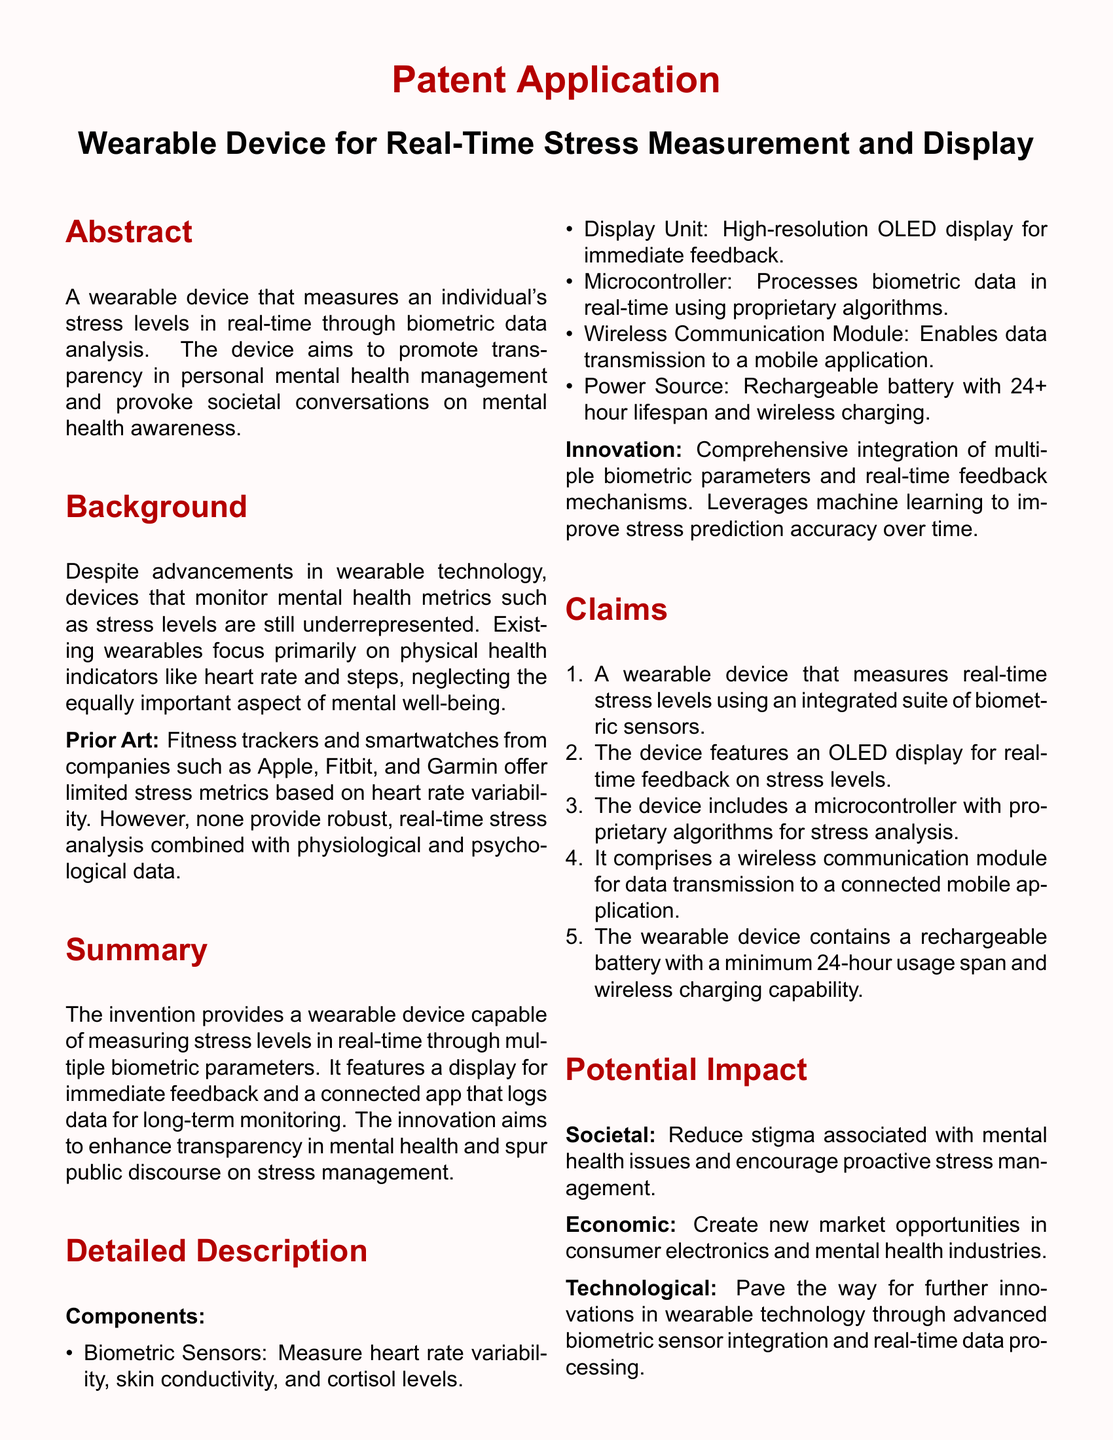What is the primary function of the wearable device? The wearable device measures an individual's stress levels in real-time through biometric data analysis.
Answer: measures stress levels How many biometric sensors are mentioned in the components of the device? The document lists biometric sensors like heart rate variability, skin conductivity, and cortisol levels, which are three in total.
Answer: three What type of display does the device use? The document specifies that the device features a high-resolution OLED display for immediate feedback.
Answer: OLED display What is the minimum battery lifespan stated in the patent? The patent mentions a rechargeable battery with a minimum 24-hour usage span.
Answer: 24-hour What societal impact does the device aim to have? The device aims to reduce stigma associated with mental health issues and encourage proactive stress management.
Answer: reduce stigma Which companies' products does the document compare the device to? The document compares the device to fitness trackers and smartwatches from companies such as Apple, Fitbit, and Garmin.
Answer: Apple, Fitbit, Garmin What innovative technology does the device utilize to improve accuracy? The device leverages machine learning to improve stress prediction accuracy over time.
Answer: machine learning What market opportunities does the device aim to create? The device aims to create new market opportunities in consumer electronics and mental health industries.
Answer: new market opportunities 